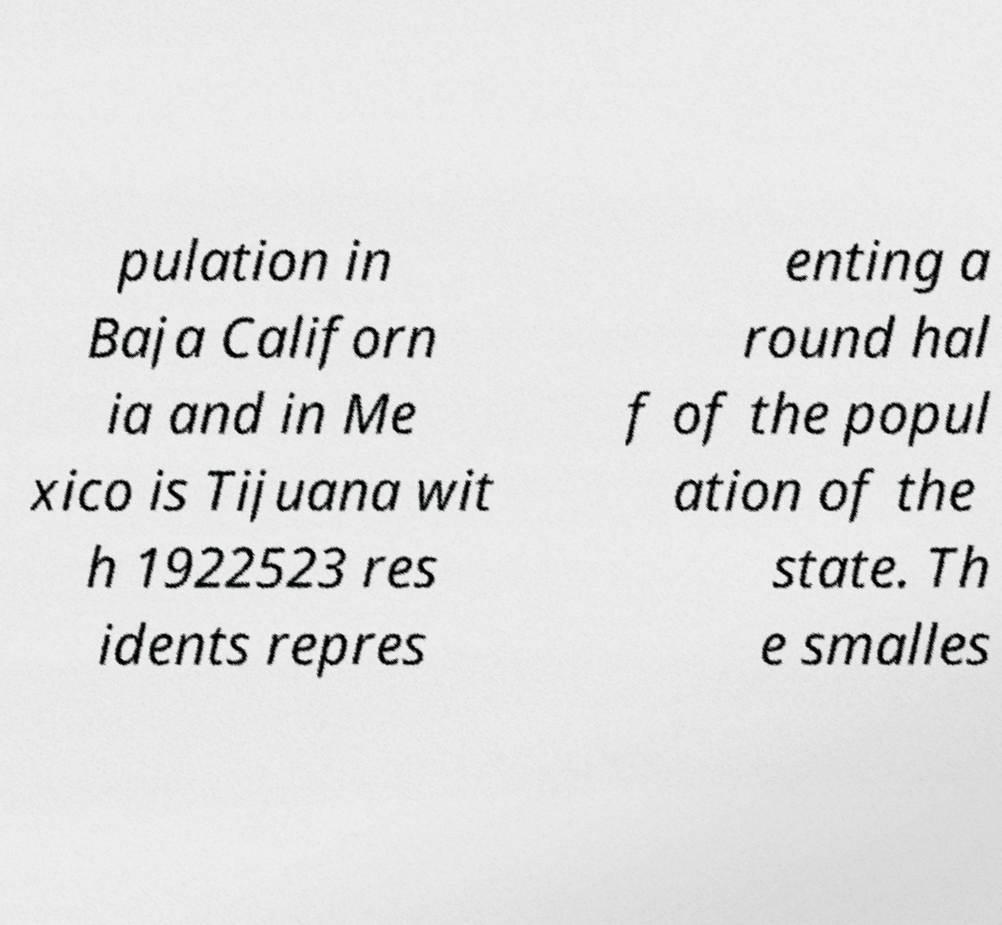Please identify and transcribe the text found in this image. pulation in Baja Californ ia and in Me xico is Tijuana wit h 1922523 res idents repres enting a round hal f of the popul ation of the state. Th e smalles 